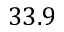Convert formula to latex. <formula><loc_0><loc_0><loc_500><loc_500>3 3 . 9</formula> 